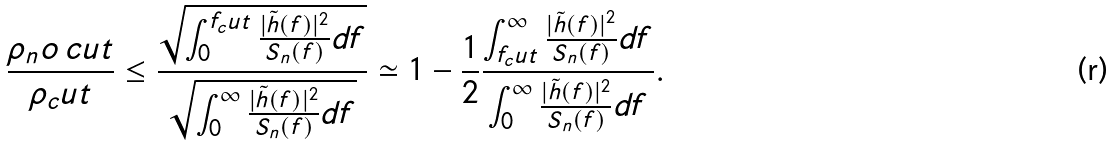<formula> <loc_0><loc_0><loc_500><loc_500>\frac { \rho _ { n } o \, c u t } { \rho _ { c } u t } \leq \frac { \sqrt { \int _ { 0 } ^ { f _ { c } u t } \frac { | \tilde { h } ( f ) | ^ { 2 } } { S _ { n } ( f ) } d f } } { \sqrt { \int _ { 0 } ^ { \infty } \frac { | \tilde { h } ( f ) | ^ { 2 } } { S _ { n } ( f ) } d f } } \simeq 1 - \frac { 1 } { 2 } \frac { \int _ { f _ { c } u t } ^ { \infty } \frac { | \tilde { h } ( f ) | ^ { 2 } } { S _ { n } ( f ) } d f } { \int _ { 0 } ^ { \infty } \frac { | \tilde { h } ( f ) | ^ { 2 } } { S _ { n } ( f ) } d f } .</formula> 